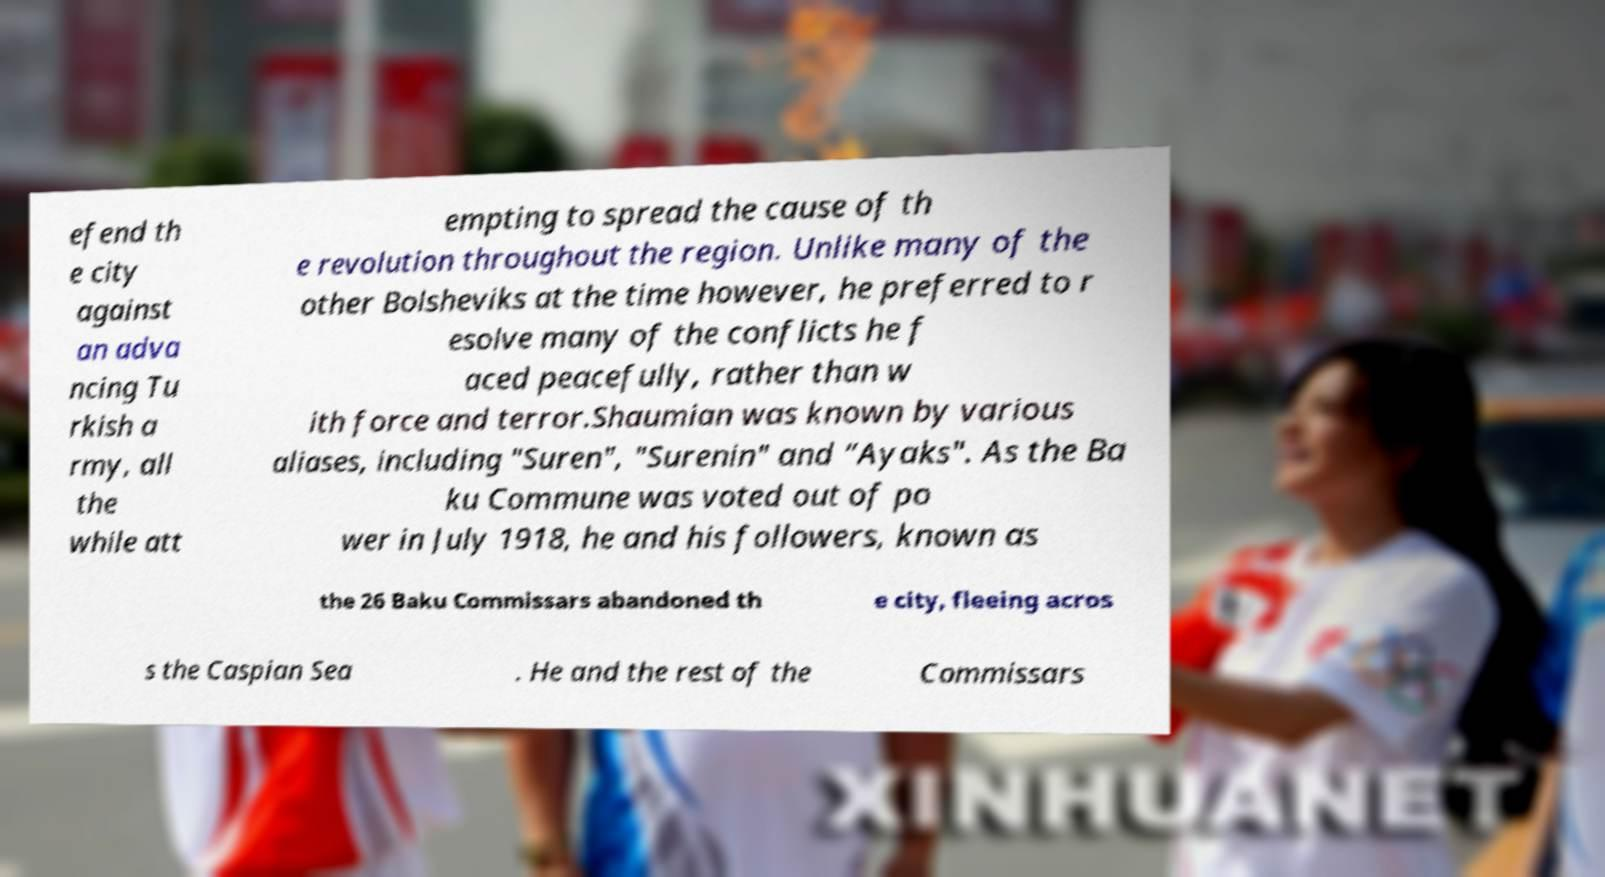Please identify and transcribe the text found in this image. efend th e city against an adva ncing Tu rkish a rmy, all the while att empting to spread the cause of th e revolution throughout the region. Unlike many of the other Bolsheviks at the time however, he preferred to r esolve many of the conflicts he f aced peacefully, rather than w ith force and terror.Shaumian was known by various aliases, including "Suren", "Surenin" and “Ayaks". As the Ba ku Commune was voted out of po wer in July 1918, he and his followers, known as the 26 Baku Commissars abandoned th e city, fleeing acros s the Caspian Sea . He and the rest of the Commissars 